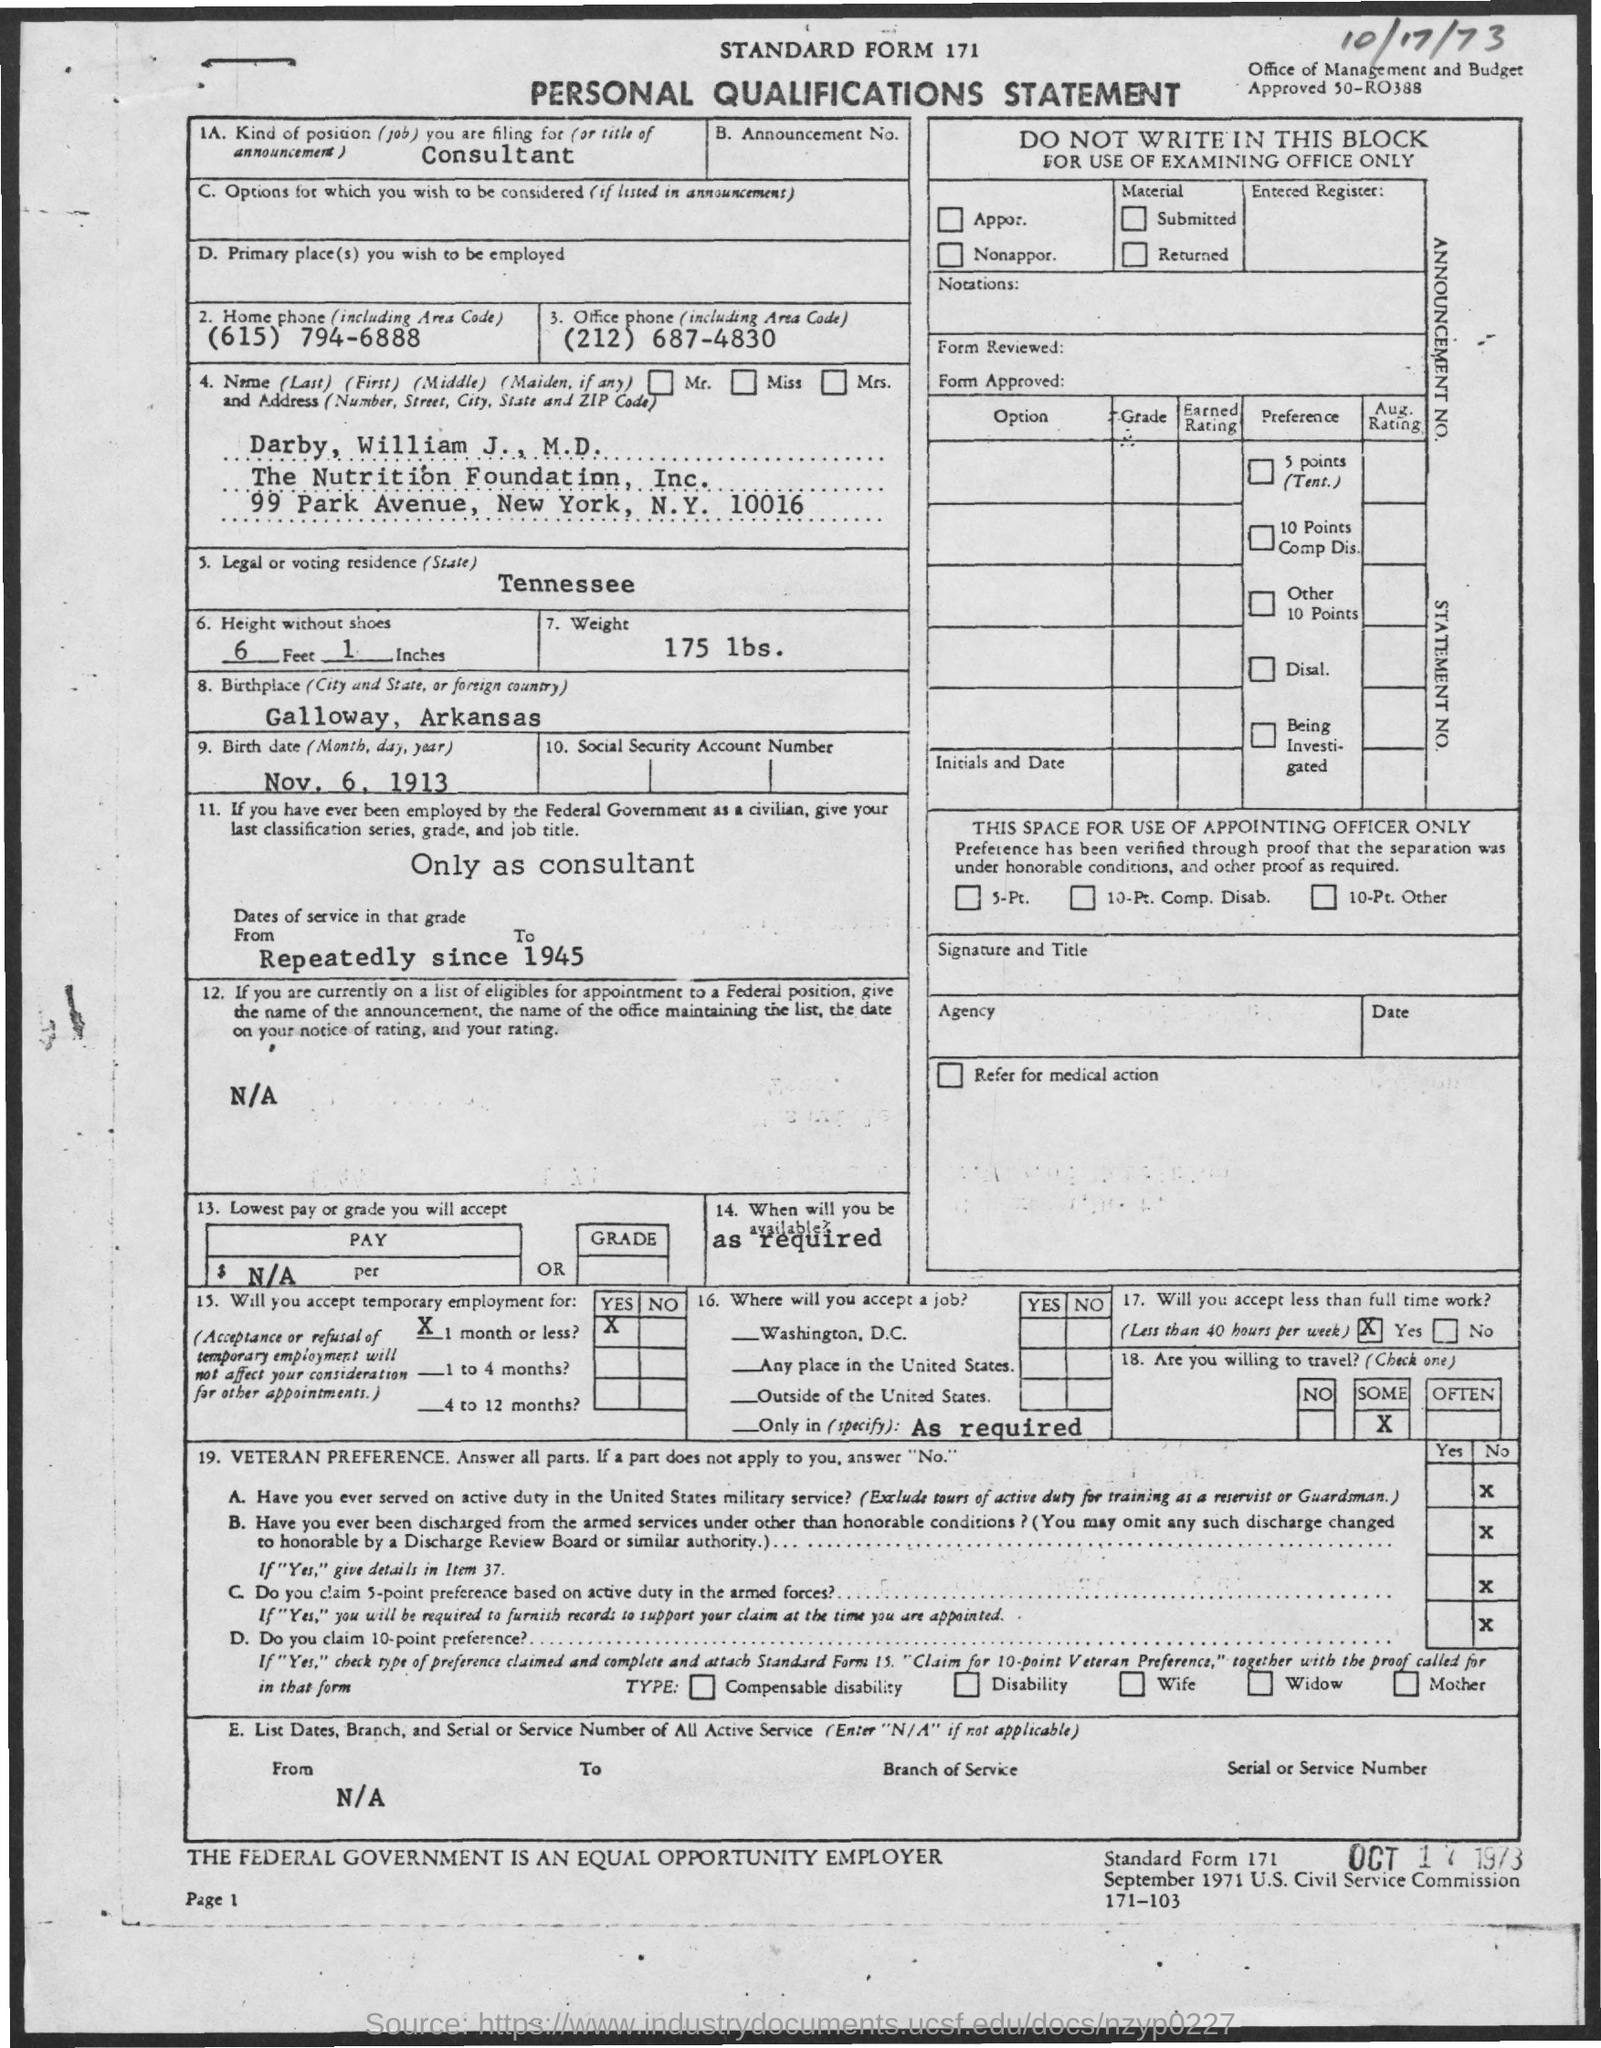What is the Title of the document?
Ensure brevity in your answer.  Personal Qualifications Statement. What is the date on the document?
Provide a short and direct response. Oct 17 1973. What is the Kind of Position being filed for?
Your answer should be compact. Consultant. What is the Home Phone?
Your answer should be very brief. (615) 794-6888. What is the Office Phone?
Your answer should be very brief. (212) 687-4830. What is the Height without shoes?
Your answer should be very brief. 6 Feet 1 Inches. What is the Weight?
Your answer should be compact. 175 lbs. What is the Birthplace?
Your answer should be very brief. Galloway, Arkansas. What is the Birth Date?
Your answer should be very brief. Nov, 6, 1913. 